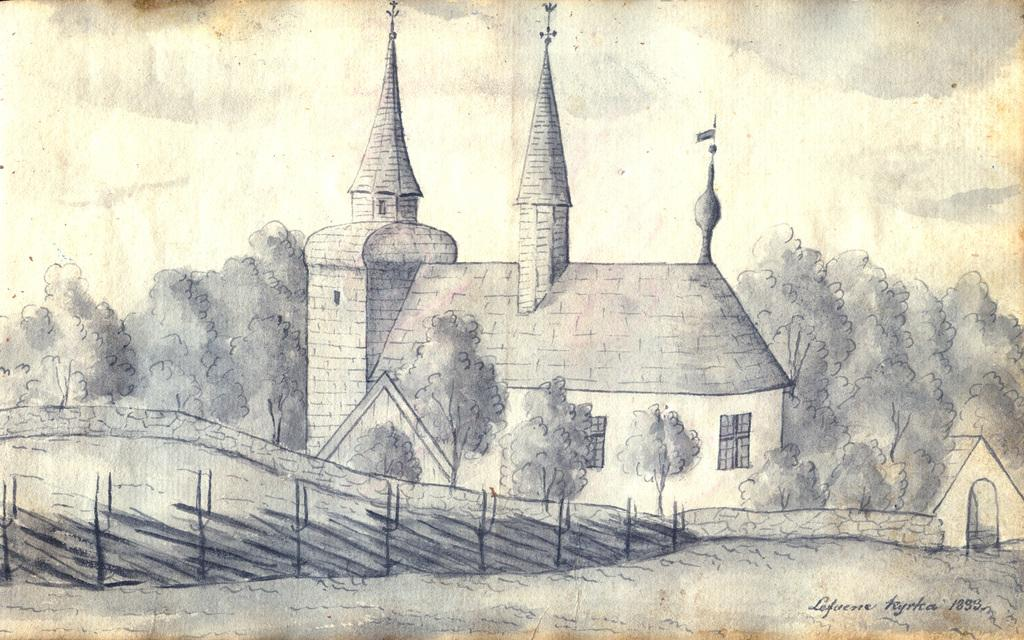What is depicted in the drawing in the image? There is a drawing of a building in the image. What specific features can be seen on the building? The building has windows. What type of natural elements are present around the building? There are trees around the building. What other living organisms are present in the image? There are plants in the image. What is visible in the background of the image? The sky is visible in the image. How would you describe the weather based on the appearance of the sky? The sky looks cloudy in the image. How many dinosaurs are playing basketball in the image? There are no dinosaurs or basketballs present in the image. 